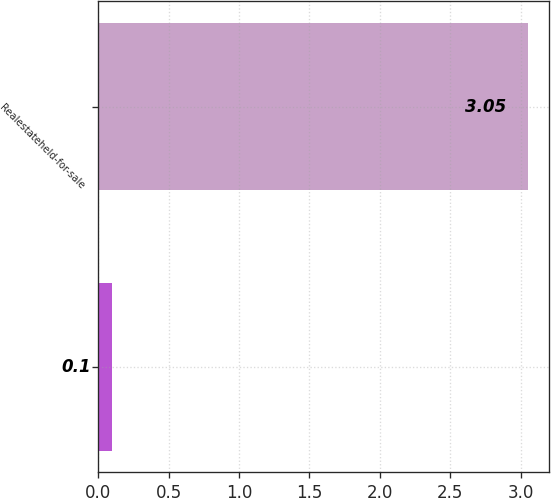Convert chart to OTSL. <chart><loc_0><loc_0><loc_500><loc_500><bar_chart><ecel><fcel>Realestateheld-for-sale<nl><fcel>0.1<fcel>3.05<nl></chart> 